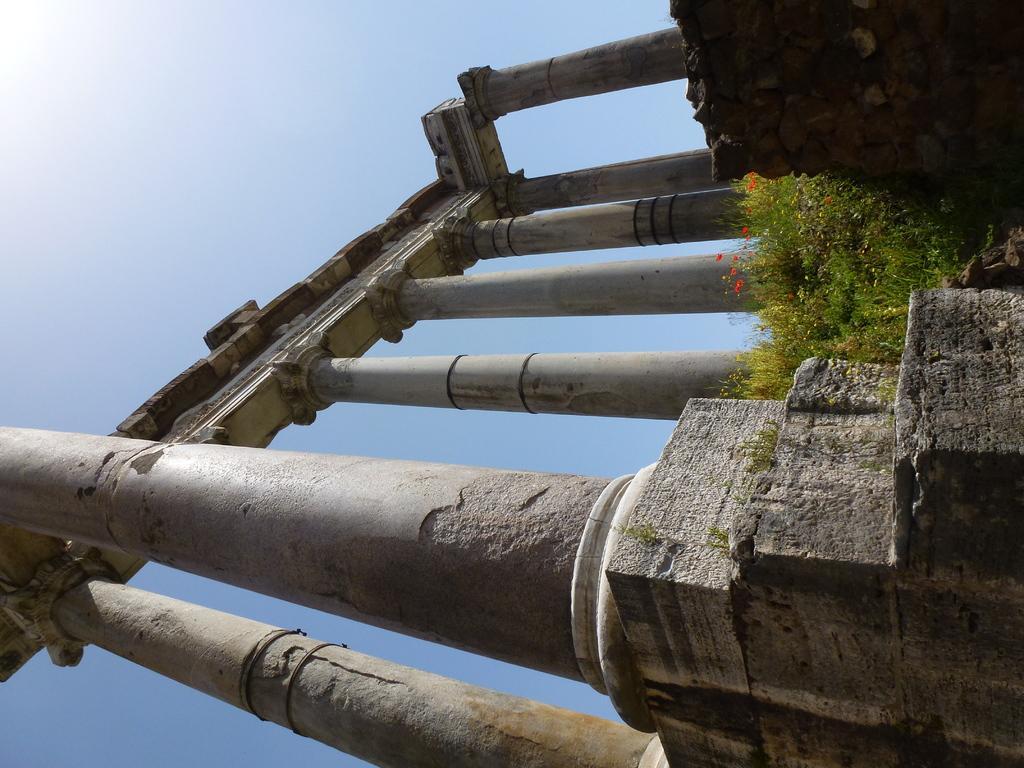Please provide a concise description of this image. In the image we can see there are poles and there are flowers on the plants. There is a clear sky. 